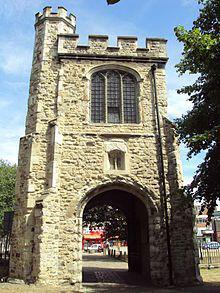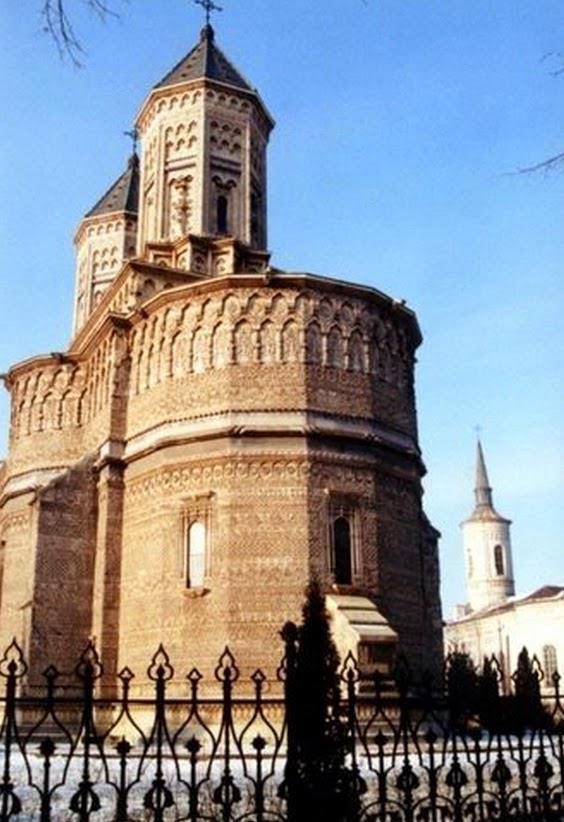The first image is the image on the left, the second image is the image on the right. For the images shown, is this caption "An image shows a tall building with a flat top that is notched like a castle." true? Answer yes or no. Yes. 